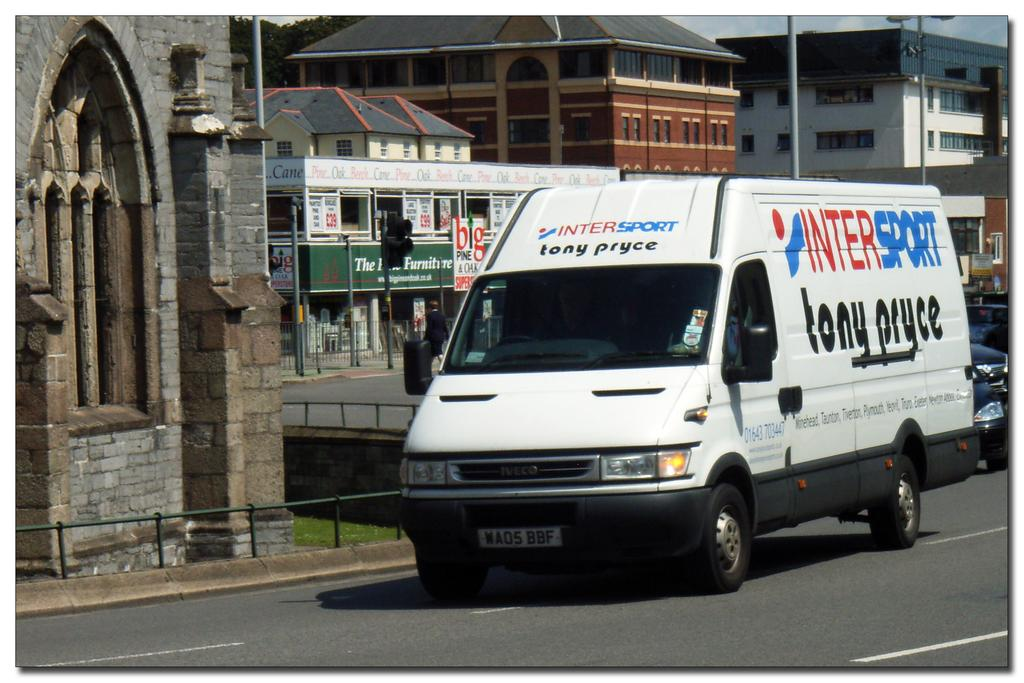What type of structures can be seen in the image? There are buildings in the image. What else can be seen in the image besides buildings? There are poles, signals, vehicles moving on the road, railing, and trees in the background. What are the poles used for in the image? The poles are likely used to support the signals. Can you describe the vehicles in the image? The vehicles are moving on the road, but their specific types cannot be determined from the image. What color is the orange hanging from the nail in the image? There is no orange or nail present in the image. 